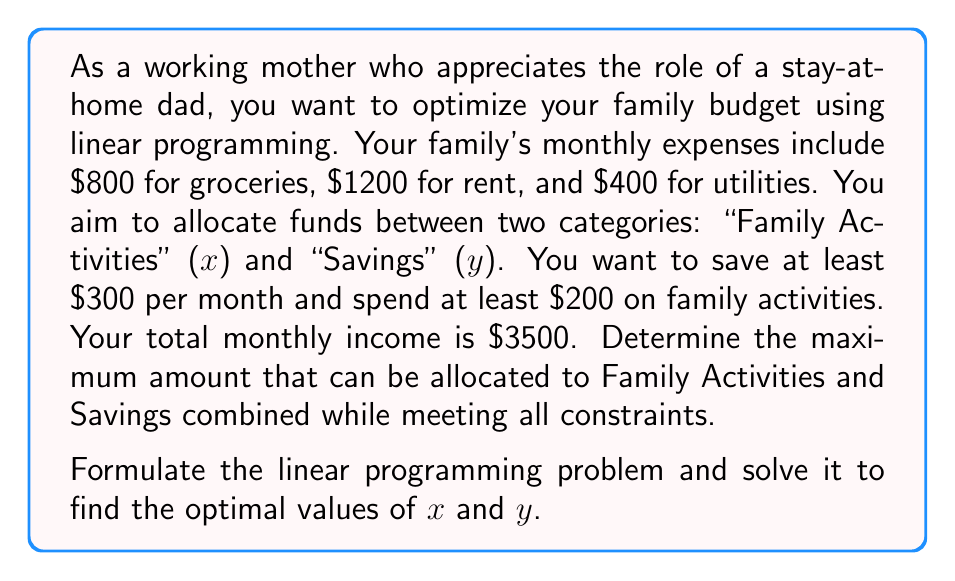Show me your answer to this math problem. Let's approach this step-by-step:

1) First, let's define our variables:
   x = amount spent on Family Activities
   y = amount saved

2) Now, let's formulate the objective function:
   Maximize: z = x + y

3) Next, we'll identify the constraints:
   a) Budget constraint: Total expenses + x + y ≤ Total income
      $800 + $1200 + $400 + x + y ≤ $3500
      2400 + x + y ≤ 3500
      x + y ≤ 1100

   b) Minimum savings: y ≥ 300

   c) Minimum family activities: x ≥ 200

   d) Non-negativity: x ≥ 0, y ≥ 0 (implied by b and c)

4) Our linear programming problem is now:

   Maximize: z = x + y
   Subject to:
   x + y ≤ 1100
   y ≥ 300
   x ≥ 200
   x, y ≥ 0

5) To solve this, we can use the graphical method:

   [asy]
   import graph;
   size(200);
   xaxis("x", 0, 1200);
   yaxis("y", 0, 1200);
   draw((0,1100)--(1100,0), blue);
   draw((0,300)--(1100,300), red);
   draw((200,0)--(200,1100), green);
   label("x + y = 1100", (550,550), NE, blue);
   label("y = 300", (550,300), N, red);
   label("x = 200", (200,550), W, green);
   fill((200,300)--(200,900)--(900,300)--cycle, lightgray);
   dot((200,900));
   dot((900,300));
   label("(200,900)", (200,900), NW);
   label("(900,300)", (900,300), SE);
   [/asy]

6) The feasible region is the shaded area. The optimal solution will be at one of the corner points. We need to evaluate z at these points:

   At (200, 900): z = 200 + 900 = 1100
   At (900, 300): z = 900 + 300 = 1200

7) Therefore, the optimal solution is at (900, 300), giving a maximum value of 1200 for x + y.
Answer: The maximum amount that can be allocated to Family Activities and Savings combined is $1200, with $900 allocated to Family Activities (x) and $300 to Savings (y). 